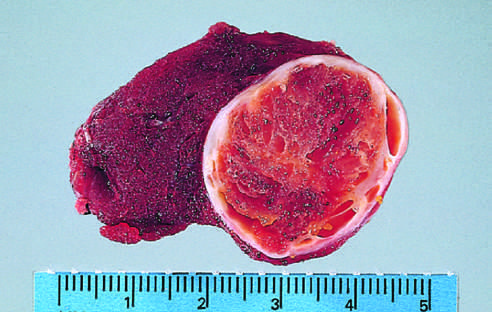s the wall of the artery composed of cells with abundant eosinophilic cytoplasm and small regular nuclei on this high-power view?
Answer the question using a single word or phrase. No 